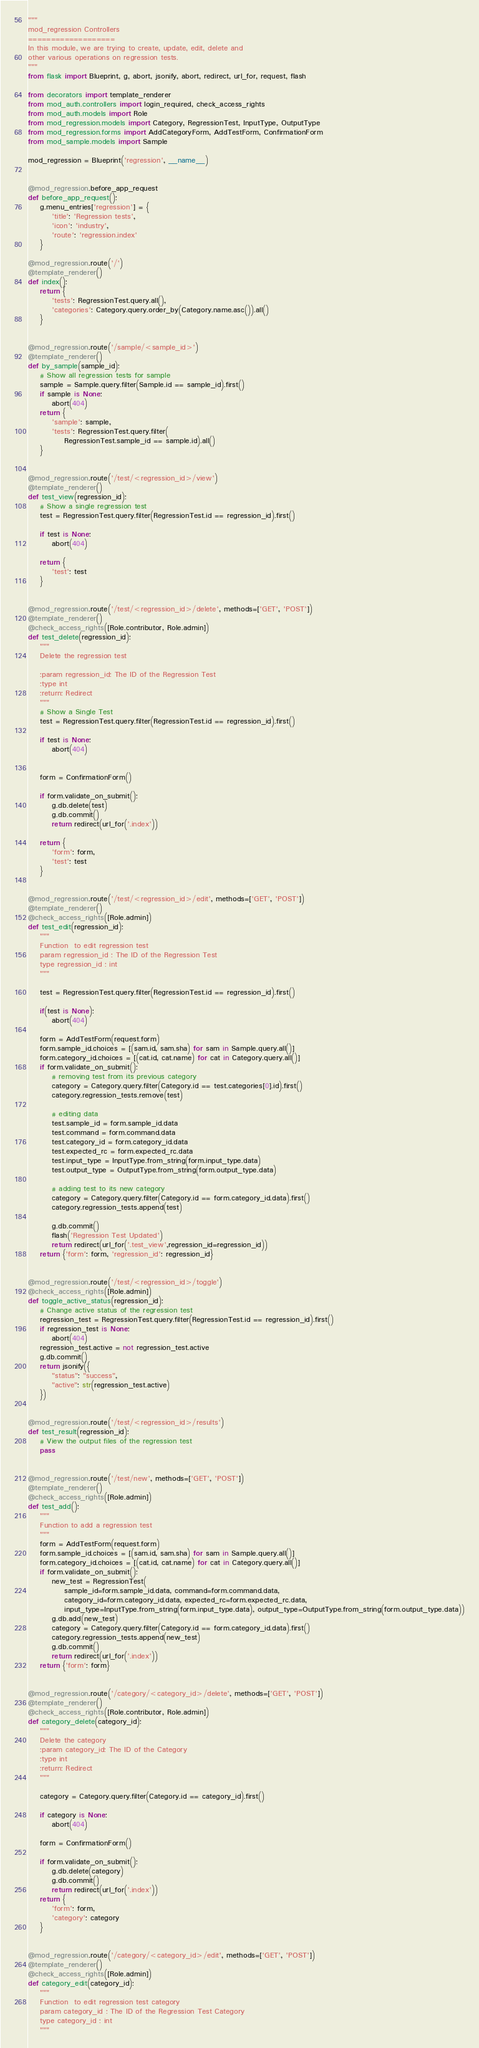<code> <loc_0><loc_0><loc_500><loc_500><_Python_>"""
mod_regression Controllers
===================
In this module, we are trying to create, update, edit, delete and
other various operations on regression tests.
"""
from flask import Blueprint, g, abort, jsonify, abort, redirect, url_for, request, flash

from decorators import template_renderer
from mod_auth.controllers import login_required, check_access_rights
from mod_auth.models import Role
from mod_regression.models import Category, RegressionTest, InputType, OutputType
from mod_regression.forms import AddCategoryForm, AddTestForm, ConfirmationForm
from mod_sample.models import Sample

mod_regression = Blueprint('regression', __name__)


@mod_regression.before_app_request
def before_app_request():
    g.menu_entries['regression'] = {
        'title': 'Regression tests',
        'icon': 'industry',
        'route': 'regression.index'
    }

@mod_regression.route('/')
@template_renderer()
def index():
    return {
        'tests': RegressionTest.query.all(),
        'categories': Category.query.order_by(Category.name.asc()).all()
    }


@mod_regression.route('/sample/<sample_id>')
@template_renderer()
def by_sample(sample_id):
    # Show all regression tests for sample
    sample = Sample.query.filter(Sample.id == sample_id).first()
    if sample is None:
        abort(404)
    return {
        'sample': sample,
        'tests': RegressionTest.query.filter(
            RegressionTest.sample_id == sample.id).all()
    }


@mod_regression.route('/test/<regression_id>/view')
@template_renderer()
def test_view(regression_id):
    # Show a single regression test
    test = RegressionTest.query.filter(RegressionTest.id == regression_id).first()

    if test is None:
        abort(404)

    return {
        'test': test
    }


@mod_regression.route('/test/<regression_id>/delete', methods=['GET', 'POST'])
@template_renderer()
@check_access_rights([Role.contributor, Role.admin])
def test_delete(regression_id):
    """
    Delete the regression test

    :param regression_id: The ID of the Regression Test
    :type int
    :return: Redirect
    """
    # Show a Single Test
    test = RegressionTest.query.filter(RegressionTest.id == regression_id).first()

    if test is None:
        abort(404)


    form = ConfirmationForm()

    if form.validate_on_submit():
        g.db.delete(test)
        g.db.commit()
        return redirect(url_for('.index'))

    return {
        'form': form,
        'test': test
    }


@mod_regression.route('/test/<regression_id>/edit', methods=['GET', 'POST'])
@template_renderer()
@check_access_rights([Role.admin])
def test_edit(regression_id):
    """
    Function  to edit regression test
    param regression_id : The ID of the Regression Test
    type regression_id : int
    """

    test = RegressionTest.query.filter(RegressionTest.id == regression_id).first()

    if(test is None):
        abort(404)

    form = AddTestForm(request.form)
    form.sample_id.choices = [(sam.id, sam.sha) for sam in Sample.query.all()]
    form.category_id.choices = [(cat.id, cat.name) for cat in Category.query.all()]
    if form.validate_on_submit():
        # removing test from its previous category
        category = Category.query.filter(Category.id == test.categories[0].id).first()
        category.regression_tests.remove(test)

        # editing data
        test.sample_id = form.sample_id.data
        test.command = form.command.data
        test.category_id = form.category_id.data
        test.expected_rc = form.expected_rc.data
        test.input_type = InputType.from_string(form.input_type.data)
        test.output_type = OutputType.from_string(form.output_type.data)

        # adding test to its new category
        category = Category.query.filter(Category.id == form.category_id.data).first()
        category.regression_tests.append(test)

        g.db.commit()
        flash('Regression Test Updated')
        return redirect(url_for('.test_view',regression_id=regression_id))
    return {'form': form, 'regression_id': regression_id}


@mod_regression.route('/test/<regression_id>/toggle')
@check_access_rights([Role.admin])
def toggle_active_status(regression_id):
    # Change active status of the regression test
    regression_test = RegressionTest.query.filter(RegressionTest.id == regression_id).first()
    if regression_test is None:
        abort(404)
    regression_test.active = not regression_test.active
    g.db.commit()
    return jsonify({
        "status": "success",
        "active": str(regression_test.active)
    })


@mod_regression.route('/test/<regression_id>/results')
def test_result(regression_id):
    # View the output files of the regression test
    pass


@mod_regression.route('/test/new', methods=['GET', 'POST'])
@template_renderer()
@check_access_rights([Role.admin])
def test_add():
    """
    Function to add a regression test
    """
    form = AddTestForm(request.form)
    form.sample_id.choices = [(sam.id, sam.sha) for sam in Sample.query.all()]
    form.category_id.choices = [(cat.id, cat.name) for cat in Category.query.all()]
    if form.validate_on_submit():
        new_test = RegressionTest(
            sample_id=form.sample_id.data, command=form.command.data,
            category_id=form.category_id.data, expected_rc=form.expected_rc.data,
            input_type=InputType.from_string(form.input_type.data), output_type=OutputType.from_string(form.output_type.data))
        g.db.add(new_test)
        category = Category.query.filter(Category.id == form.category_id.data).first()
        category.regression_tests.append(new_test)
        g.db.commit()
        return redirect(url_for('.index'))
    return {'form': form}


@mod_regression.route('/category/<category_id>/delete', methods=['GET', 'POST'])
@template_renderer()
@check_access_rights([Role.contributor, Role.admin])
def category_delete(category_id):
    """
    Delete the category
    :param category_id: The ID of the Category
    :type int
    :return: Redirect
    """

    category = Category.query.filter(Category.id == category_id).first()

    if category is None:
        abort(404)

    form = ConfirmationForm()

    if form.validate_on_submit():
        g.db.delete(category)
        g.db.commit()
        return redirect(url_for('.index'))
    return {
        'form': form,
        'category': category
    }


@mod_regression.route('/category/<category_id>/edit', methods=['GET', 'POST'])
@template_renderer()
@check_access_rights([Role.admin])
def category_edit(category_id):
    """
    Function  to edit regression test category
    param category_id : The ID of the Regression Test Category
    type category_id : int
    """
</code> 